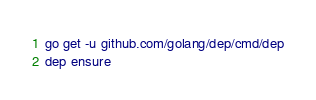Convert code to text. <code><loc_0><loc_0><loc_500><loc_500><_Bash_>go get -u github.com/golang/dep/cmd/dep
dep ensure</code> 